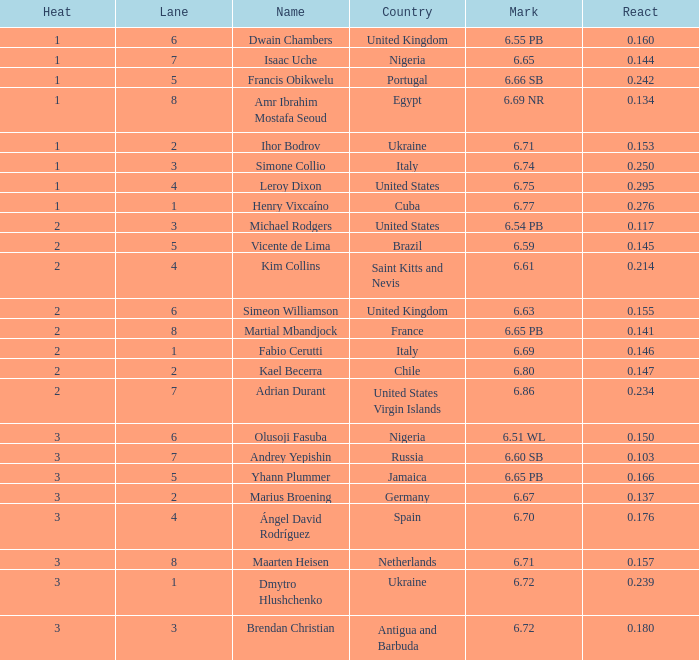What is temperature, when mark is 2.0. 